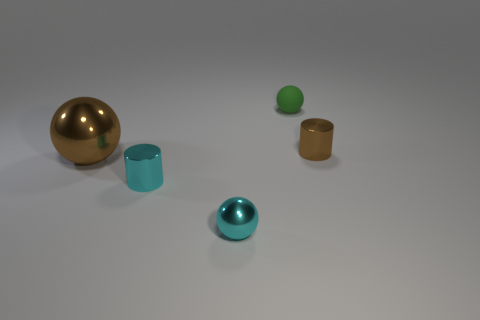Subtract all shiny balls. How many balls are left? 1 Subtract all green spheres. How many spheres are left? 2 Add 4 tiny yellow matte blocks. How many objects exist? 9 Subtract all cylinders. How many objects are left? 3 Subtract 2 cylinders. How many cylinders are left? 0 Add 4 small metallic cylinders. How many small metallic cylinders are left? 6 Add 2 small cyan spheres. How many small cyan spheres exist? 3 Subtract 0 yellow balls. How many objects are left? 5 Subtract all green cylinders. Subtract all red spheres. How many cylinders are left? 2 Subtract all brown spheres. How many brown cylinders are left? 1 